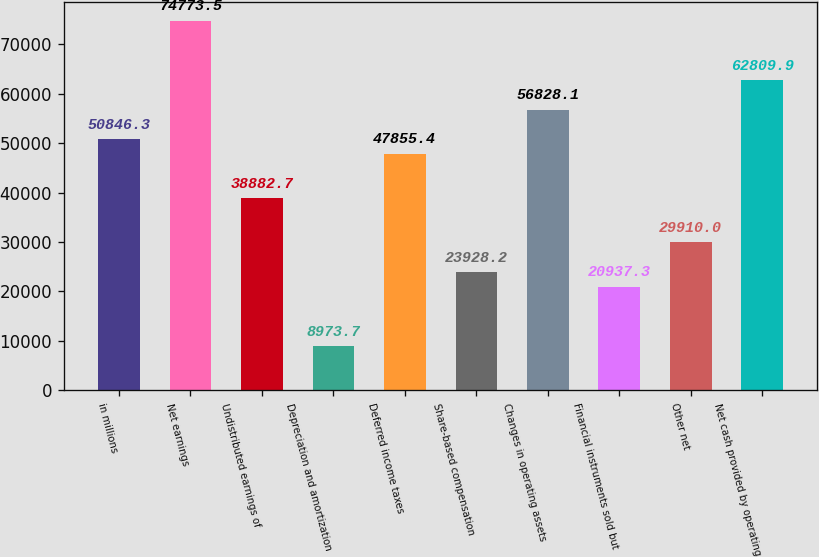Convert chart. <chart><loc_0><loc_0><loc_500><loc_500><bar_chart><fcel>in millions<fcel>Net earnings<fcel>Undistributed earnings of<fcel>Depreciation and amortization<fcel>Deferred income taxes<fcel>Share-based compensation<fcel>Changes in operating assets<fcel>Financial instruments sold but<fcel>Other net<fcel>Net cash provided by operating<nl><fcel>50846.3<fcel>74773.5<fcel>38882.7<fcel>8973.7<fcel>47855.4<fcel>23928.2<fcel>56828.1<fcel>20937.3<fcel>29910<fcel>62809.9<nl></chart> 